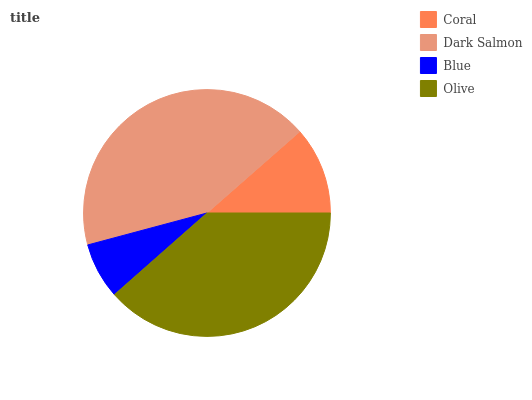Is Blue the minimum?
Answer yes or no. Yes. Is Dark Salmon the maximum?
Answer yes or no. Yes. Is Dark Salmon the minimum?
Answer yes or no. No. Is Blue the maximum?
Answer yes or no. No. Is Dark Salmon greater than Blue?
Answer yes or no. Yes. Is Blue less than Dark Salmon?
Answer yes or no. Yes. Is Blue greater than Dark Salmon?
Answer yes or no. No. Is Dark Salmon less than Blue?
Answer yes or no. No. Is Olive the high median?
Answer yes or no. Yes. Is Coral the low median?
Answer yes or no. Yes. Is Blue the high median?
Answer yes or no. No. Is Blue the low median?
Answer yes or no. No. 